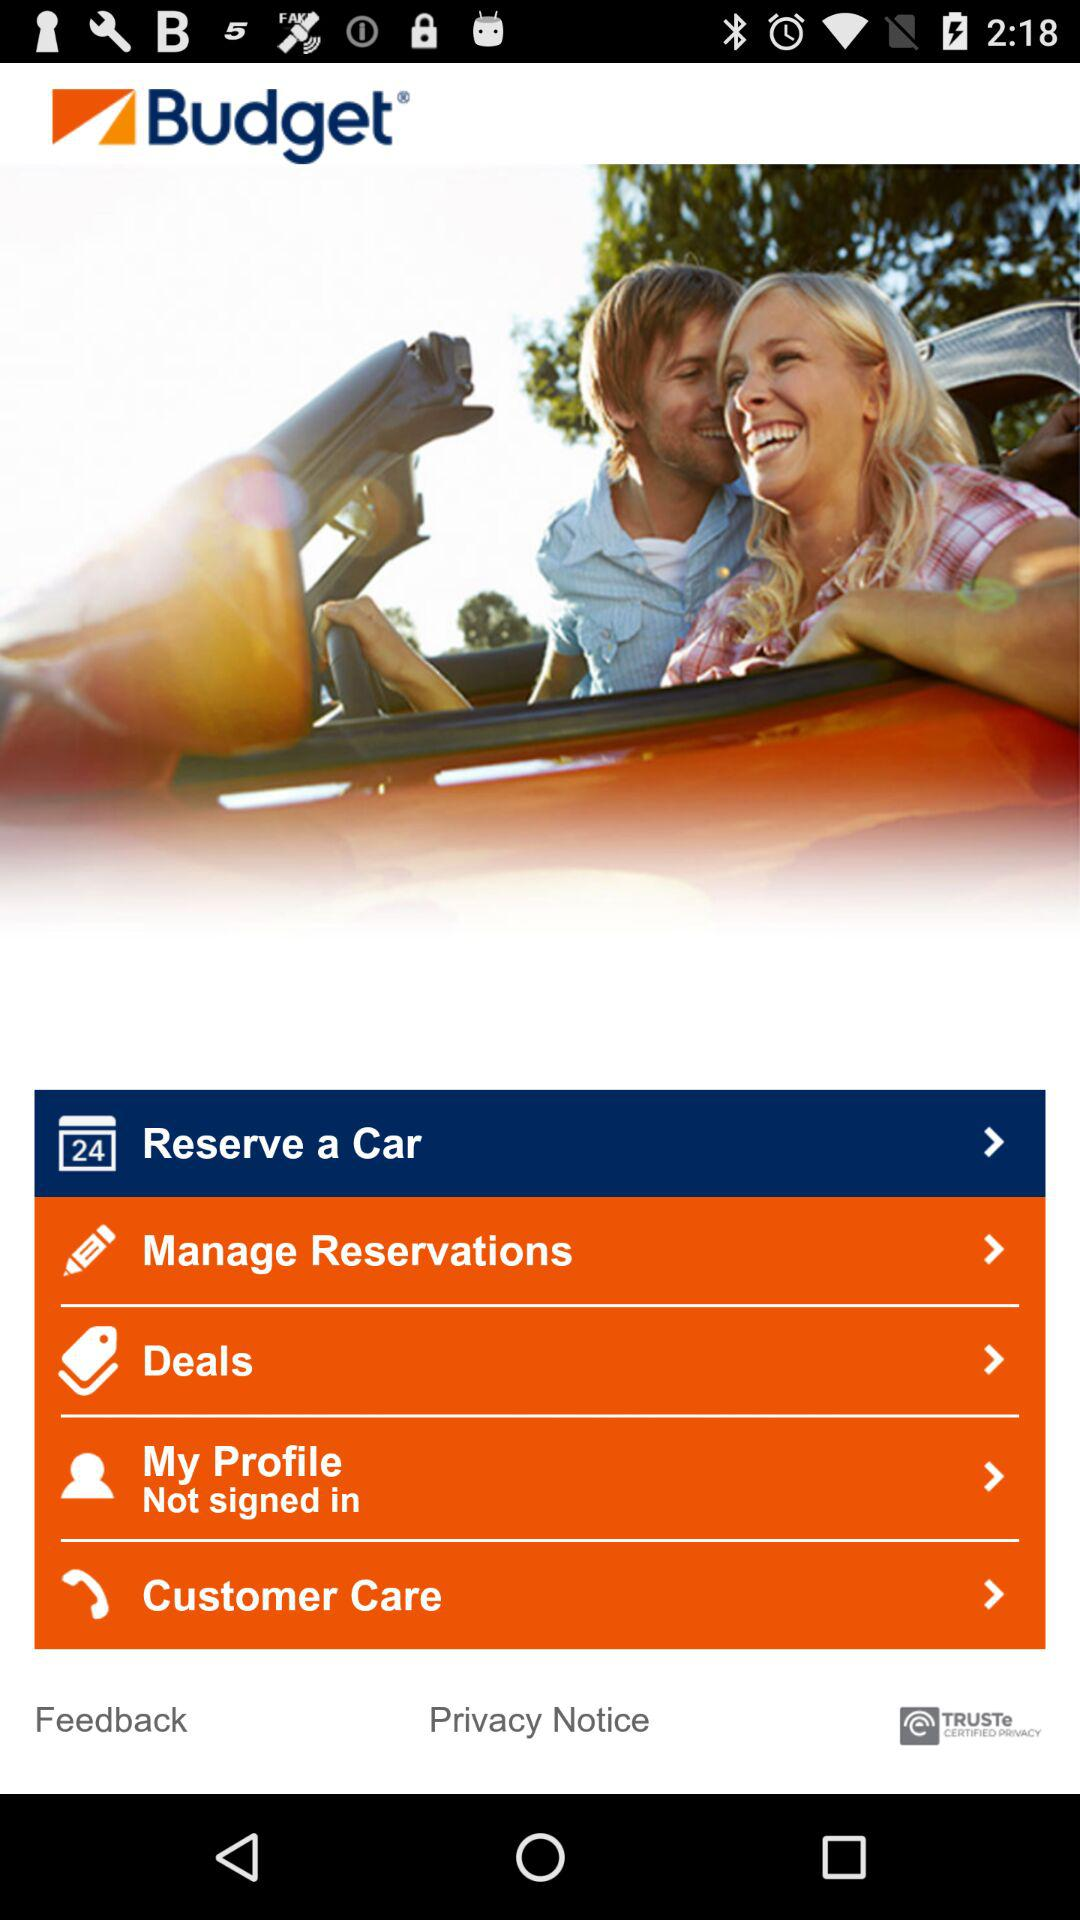What is the name of the application? The name of the application is "Budget". 